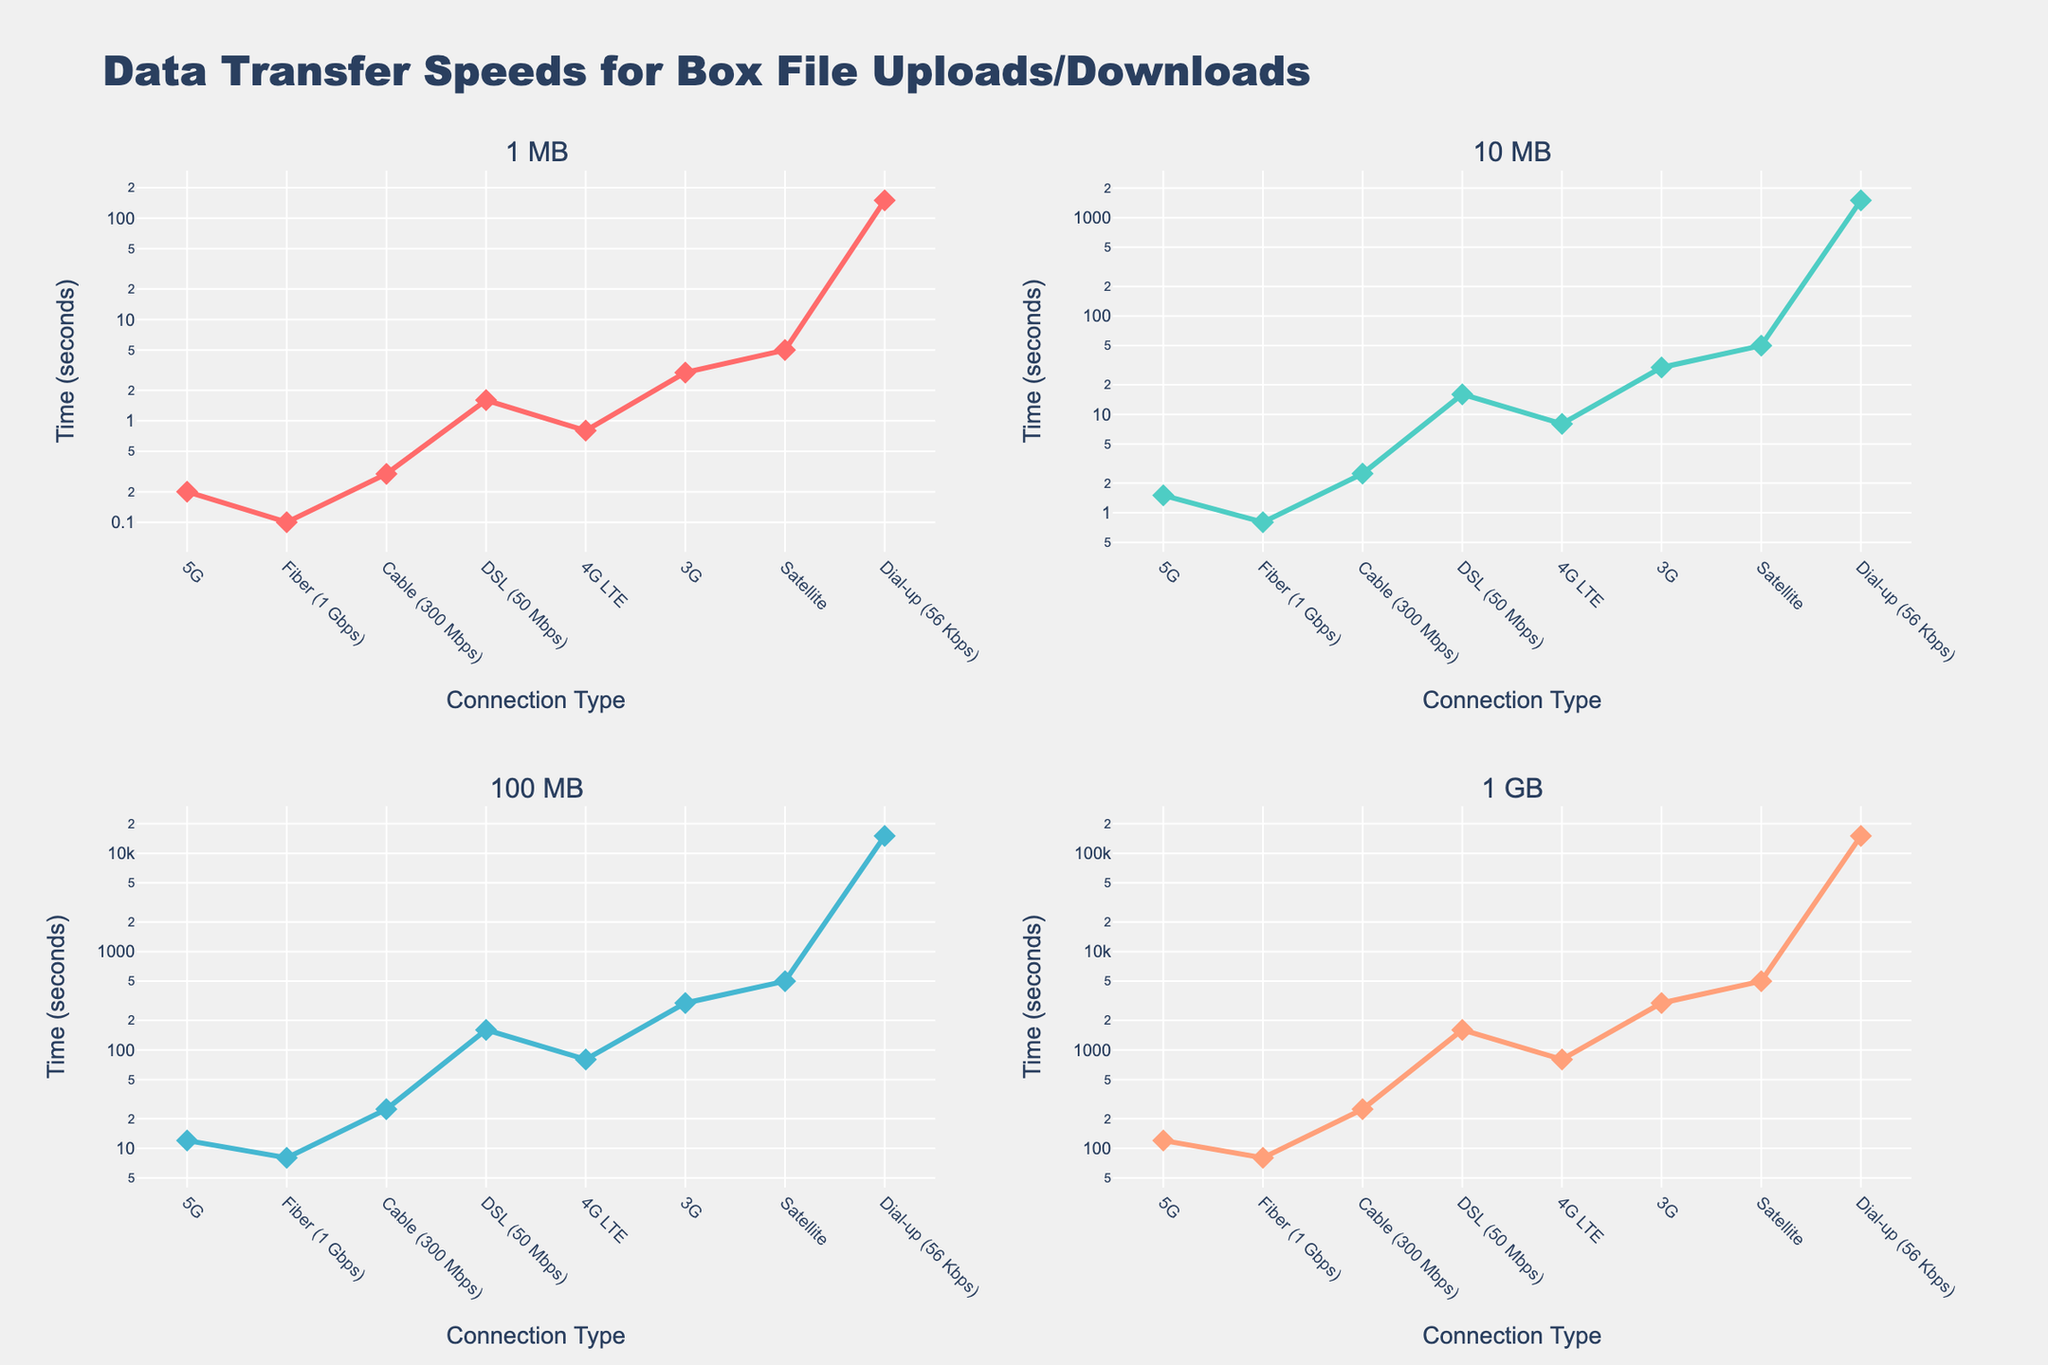Which connection type has the fastest upload/download speed for a 100 MB file? The subplot for 100 MB shows that Fiber (1 Gbps) has the lowest value, indicating the fastest speed for a 100 MB file.
Answer: Fiber (1 Gbps) How many times slower is the DSL connection compared to the Fiber connection for a 10 MB file? The subplot for 10 MB files shows that DSL takes 16 seconds while Fiber takes 0.8 seconds. The ratio is 16 / 0.8 = 20 times slower.
Answer: 20 times For which connection types does it take more than 1000 seconds to upload/download a 1 GB file? The subplot for 1 GB files shows that 3G, Satellite, and Dial-up connections all take more than 1000 seconds.
Answer: 3G, Satellite, Dial-up What's the total time required to upload/download 1 MB, 10 MB, 100 MB, and 1 GB files on a 4G LTE connection? Summing the times from the 4G LTE rows: 0.8 (1 MB) + 8 (10 MB) + 80 (100 MB) + 800 (1 GB) = 888.8 seconds.
Answer: 888.8 seconds Which connection shows the greatest difference in upload/download times between 1 MB and 1 GB files? The Dial-up connection shows the largest difference; 150,000 seconds (1 GB) - 150 seconds (1 MB) = 149,850 seconds.
Answer: Dial-up How does the time for 1 MB file transfer on a 3G connection compare with a 100 MB transfer on a 5G connection? For 1 MB on 3G, it takes 3 seconds, while for 100 MB on 5G, it takes 12 seconds. Therefore, 1 MB on 3G is faster than 100 MB on 5G.
Answer: 3G is faster Which connection type takes the longest time for transferring a 10 MB file, and how much longer is it compared to the second slowest connection? The subplot for 10 MB files shows Dial-up taking 1500 seconds, the slowest. The second slowest is Satellite at 50 seconds. The difference is 1500 - 50 = 1450 seconds.
Answer: Dial-up, 1450 seconds If you were to upload/download 10 MB using Fiber and Cable connections, how much total time would that take? The subplot for 10 MB files shows it takes 0.8 seconds on Fiber and 2.5 seconds on Cable. Total time = 0.8 + 2.5 = 3.3 seconds.
Answer: 3.3 seconds Which connection types show equal or greater times for 10 MB transfers compared to 1 MB transfers on Satellite? Satellite takes 5 seconds for 1 MB. The subplot for 10 MB files shows DSL (16s), 3G (30s), and Dial-up (1500s) all above 5 seconds.
Answer: DSL, 3G, Dial-up 